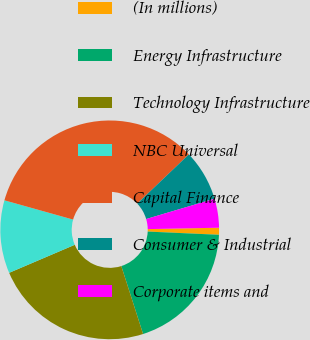Convert chart to OTSL. <chart><loc_0><loc_0><loc_500><loc_500><pie_chart><fcel>(In millions)<fcel>Energy Infrastructure<fcel>Technology Infrastructure<fcel>NBC Universal<fcel>Capital Finance<fcel>Consumer & Industrial<fcel>Corporate items and<nl><fcel>1.03%<fcel>19.35%<fcel>23.51%<fcel>10.78%<fcel>33.53%<fcel>7.53%<fcel>4.28%<nl></chart> 